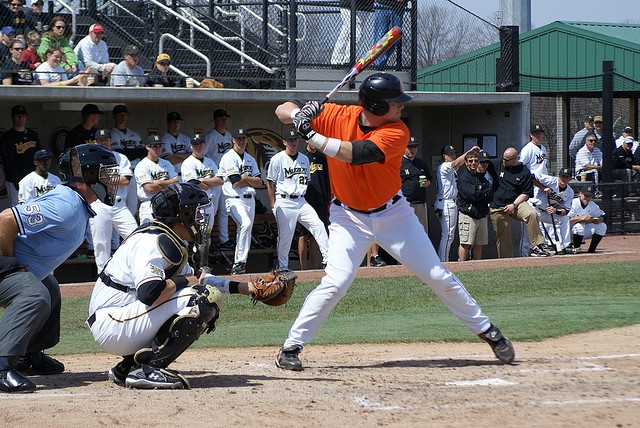Describe the objects in this image and their specific colors. I can see people in black, gray, brown, and white tones, people in black, gray, lightgray, and darkgray tones, people in black, white, gray, and darkgray tones, people in black, gray, and navy tones, and people in black, white, and darkgray tones in this image. 